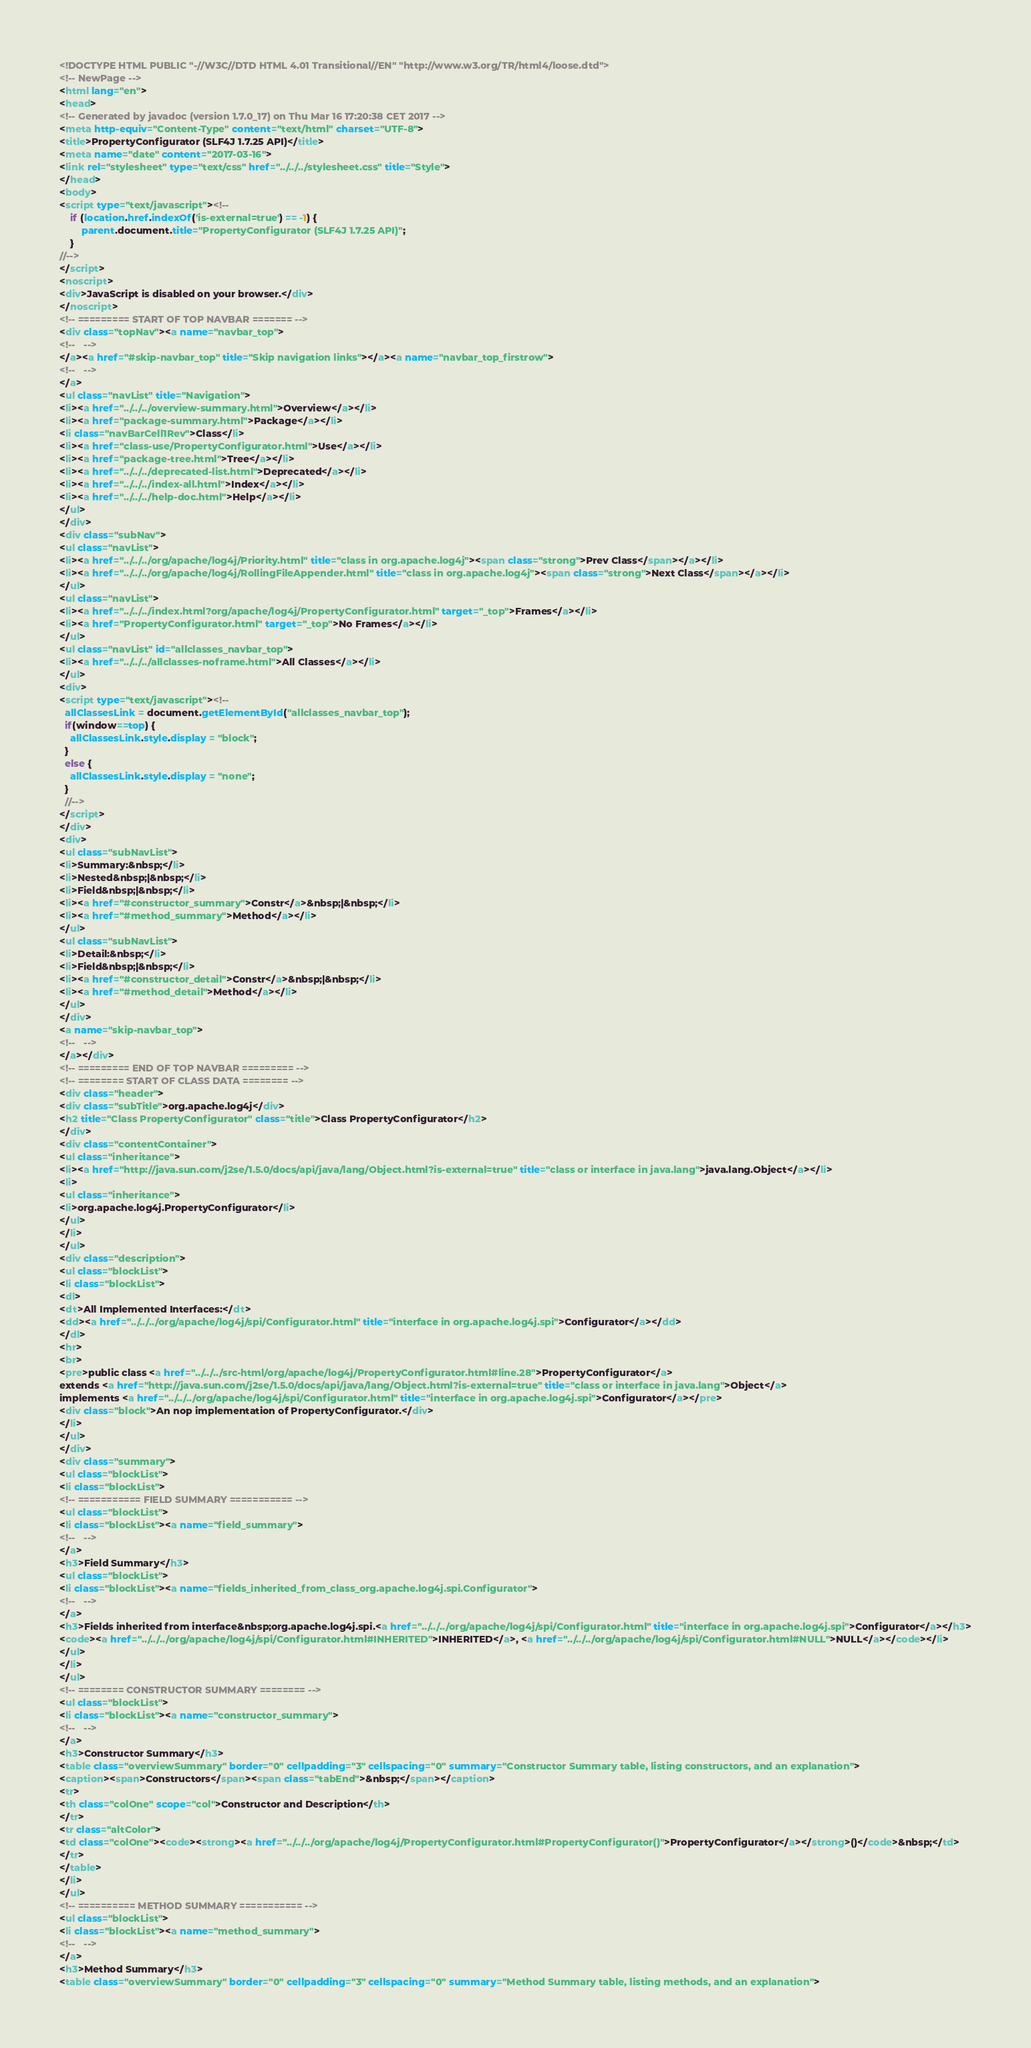<code> <loc_0><loc_0><loc_500><loc_500><_HTML_><!DOCTYPE HTML PUBLIC "-//W3C//DTD HTML 4.01 Transitional//EN" "http://www.w3.org/TR/html4/loose.dtd">
<!-- NewPage -->
<html lang="en">
<head>
<!-- Generated by javadoc (version 1.7.0_17) on Thu Mar 16 17:20:38 CET 2017 -->
<meta http-equiv="Content-Type" content="text/html" charset="UTF-8">
<title>PropertyConfigurator (SLF4J 1.7.25 API)</title>
<meta name="date" content="2017-03-16">
<link rel="stylesheet" type="text/css" href="../../../stylesheet.css" title="Style">
</head>
<body>
<script type="text/javascript"><!--
    if (location.href.indexOf('is-external=true') == -1) {
        parent.document.title="PropertyConfigurator (SLF4J 1.7.25 API)";
    }
//-->
</script>
<noscript>
<div>JavaScript is disabled on your browser.</div>
</noscript>
<!-- ========= START OF TOP NAVBAR ======= -->
<div class="topNav"><a name="navbar_top">
<!--   -->
</a><a href="#skip-navbar_top" title="Skip navigation links"></a><a name="navbar_top_firstrow">
<!--   -->
</a>
<ul class="navList" title="Navigation">
<li><a href="../../../overview-summary.html">Overview</a></li>
<li><a href="package-summary.html">Package</a></li>
<li class="navBarCell1Rev">Class</li>
<li><a href="class-use/PropertyConfigurator.html">Use</a></li>
<li><a href="package-tree.html">Tree</a></li>
<li><a href="../../../deprecated-list.html">Deprecated</a></li>
<li><a href="../../../index-all.html">Index</a></li>
<li><a href="../../../help-doc.html">Help</a></li>
</ul>
</div>
<div class="subNav">
<ul class="navList">
<li><a href="../../../org/apache/log4j/Priority.html" title="class in org.apache.log4j"><span class="strong">Prev Class</span></a></li>
<li><a href="../../../org/apache/log4j/RollingFileAppender.html" title="class in org.apache.log4j"><span class="strong">Next Class</span></a></li>
</ul>
<ul class="navList">
<li><a href="../../../index.html?org/apache/log4j/PropertyConfigurator.html" target="_top">Frames</a></li>
<li><a href="PropertyConfigurator.html" target="_top">No Frames</a></li>
</ul>
<ul class="navList" id="allclasses_navbar_top">
<li><a href="../../../allclasses-noframe.html">All Classes</a></li>
</ul>
<div>
<script type="text/javascript"><!--
  allClassesLink = document.getElementById("allclasses_navbar_top");
  if(window==top) {
    allClassesLink.style.display = "block";
  }
  else {
    allClassesLink.style.display = "none";
  }
  //-->
</script>
</div>
<div>
<ul class="subNavList">
<li>Summary:&nbsp;</li>
<li>Nested&nbsp;|&nbsp;</li>
<li>Field&nbsp;|&nbsp;</li>
<li><a href="#constructor_summary">Constr</a>&nbsp;|&nbsp;</li>
<li><a href="#method_summary">Method</a></li>
</ul>
<ul class="subNavList">
<li>Detail:&nbsp;</li>
<li>Field&nbsp;|&nbsp;</li>
<li><a href="#constructor_detail">Constr</a>&nbsp;|&nbsp;</li>
<li><a href="#method_detail">Method</a></li>
</ul>
</div>
<a name="skip-navbar_top">
<!--   -->
</a></div>
<!-- ========= END OF TOP NAVBAR ========= -->
<!-- ======== START OF CLASS DATA ======== -->
<div class="header">
<div class="subTitle">org.apache.log4j</div>
<h2 title="Class PropertyConfigurator" class="title">Class PropertyConfigurator</h2>
</div>
<div class="contentContainer">
<ul class="inheritance">
<li><a href="http://java.sun.com/j2se/1.5.0/docs/api/java/lang/Object.html?is-external=true" title="class or interface in java.lang">java.lang.Object</a></li>
<li>
<ul class="inheritance">
<li>org.apache.log4j.PropertyConfigurator</li>
</ul>
</li>
</ul>
<div class="description">
<ul class="blockList">
<li class="blockList">
<dl>
<dt>All Implemented Interfaces:</dt>
<dd><a href="../../../org/apache/log4j/spi/Configurator.html" title="interface in org.apache.log4j.spi">Configurator</a></dd>
</dl>
<hr>
<br>
<pre>public class <a href="../../../src-html/org/apache/log4j/PropertyConfigurator.html#line.28">PropertyConfigurator</a>
extends <a href="http://java.sun.com/j2se/1.5.0/docs/api/java/lang/Object.html?is-external=true" title="class or interface in java.lang">Object</a>
implements <a href="../../../org/apache/log4j/spi/Configurator.html" title="interface in org.apache.log4j.spi">Configurator</a></pre>
<div class="block">An nop implementation of PropertyConfigurator.</div>
</li>
</ul>
</div>
<div class="summary">
<ul class="blockList">
<li class="blockList">
<!-- =========== FIELD SUMMARY =========== -->
<ul class="blockList">
<li class="blockList"><a name="field_summary">
<!--   -->
</a>
<h3>Field Summary</h3>
<ul class="blockList">
<li class="blockList"><a name="fields_inherited_from_class_org.apache.log4j.spi.Configurator">
<!--   -->
</a>
<h3>Fields inherited from interface&nbsp;org.apache.log4j.spi.<a href="../../../org/apache/log4j/spi/Configurator.html" title="interface in org.apache.log4j.spi">Configurator</a></h3>
<code><a href="../../../org/apache/log4j/spi/Configurator.html#INHERITED">INHERITED</a>, <a href="../../../org/apache/log4j/spi/Configurator.html#NULL">NULL</a></code></li>
</ul>
</li>
</ul>
<!-- ======== CONSTRUCTOR SUMMARY ======== -->
<ul class="blockList">
<li class="blockList"><a name="constructor_summary">
<!--   -->
</a>
<h3>Constructor Summary</h3>
<table class="overviewSummary" border="0" cellpadding="3" cellspacing="0" summary="Constructor Summary table, listing constructors, and an explanation">
<caption><span>Constructors</span><span class="tabEnd">&nbsp;</span></caption>
<tr>
<th class="colOne" scope="col">Constructor and Description</th>
</tr>
<tr class="altColor">
<td class="colOne"><code><strong><a href="../../../org/apache/log4j/PropertyConfigurator.html#PropertyConfigurator()">PropertyConfigurator</a></strong>()</code>&nbsp;</td>
</tr>
</table>
</li>
</ul>
<!-- ========== METHOD SUMMARY =========== -->
<ul class="blockList">
<li class="blockList"><a name="method_summary">
<!--   -->
</a>
<h3>Method Summary</h3>
<table class="overviewSummary" border="0" cellpadding="3" cellspacing="0" summary="Method Summary table, listing methods, and an explanation"></code> 